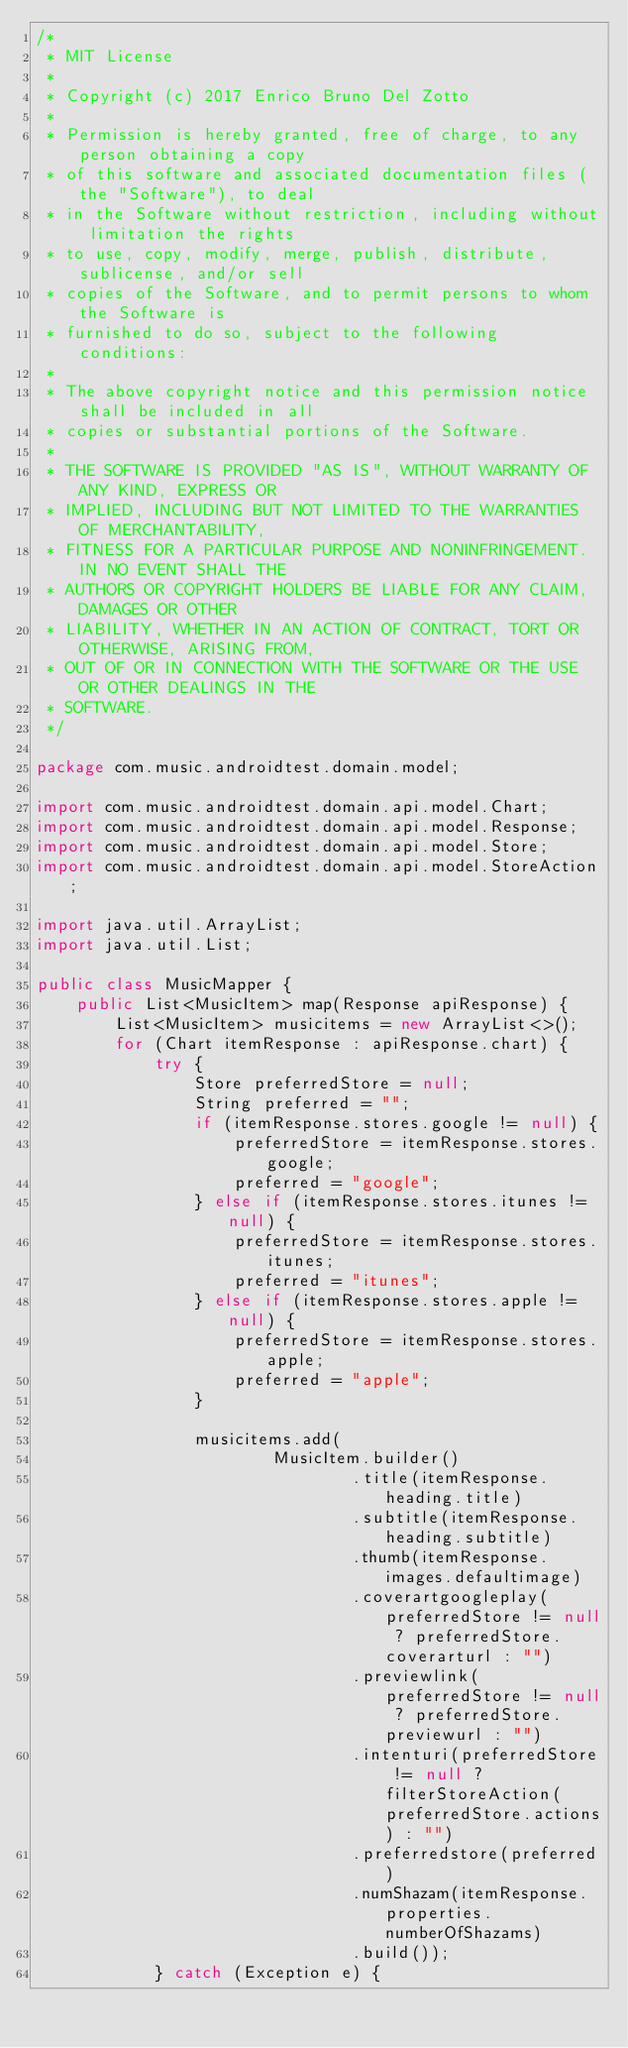Convert code to text. <code><loc_0><loc_0><loc_500><loc_500><_Java_>/*
 * MIT License
 *
 * Copyright (c) 2017 Enrico Bruno Del Zotto
 *
 * Permission is hereby granted, free of charge, to any person obtaining a copy
 * of this software and associated documentation files (the "Software"), to deal
 * in the Software without restriction, including without limitation the rights
 * to use, copy, modify, merge, publish, distribute, sublicense, and/or sell
 * copies of the Software, and to permit persons to whom the Software is
 * furnished to do so, subject to the following conditions:
 *
 * The above copyright notice and this permission notice shall be included in all
 * copies or substantial portions of the Software.
 *
 * THE SOFTWARE IS PROVIDED "AS IS", WITHOUT WARRANTY OF ANY KIND, EXPRESS OR
 * IMPLIED, INCLUDING BUT NOT LIMITED TO THE WARRANTIES OF MERCHANTABILITY,
 * FITNESS FOR A PARTICULAR PURPOSE AND NONINFRINGEMENT. IN NO EVENT SHALL THE
 * AUTHORS OR COPYRIGHT HOLDERS BE LIABLE FOR ANY CLAIM, DAMAGES OR OTHER
 * LIABILITY, WHETHER IN AN ACTION OF CONTRACT, TORT OR OTHERWISE, ARISING FROM,
 * OUT OF OR IN CONNECTION WITH THE SOFTWARE OR THE USE OR OTHER DEALINGS IN THE
 * SOFTWARE.
 */

package com.music.androidtest.domain.model;

import com.music.androidtest.domain.api.model.Chart;
import com.music.androidtest.domain.api.model.Response;
import com.music.androidtest.domain.api.model.Store;
import com.music.androidtest.domain.api.model.StoreAction;

import java.util.ArrayList;
import java.util.List;

public class MusicMapper {
    public List<MusicItem> map(Response apiResponse) {
        List<MusicItem> musicitems = new ArrayList<>();
        for (Chart itemResponse : apiResponse.chart) {
            try {
                Store preferredStore = null;
                String preferred = "";
                if (itemResponse.stores.google != null) {
                    preferredStore = itemResponse.stores.google;
                    preferred = "google";
                } else if (itemResponse.stores.itunes != null) {
                    preferredStore = itemResponse.stores.itunes;
                    preferred = "itunes";
                } else if (itemResponse.stores.apple != null) {
                    preferredStore = itemResponse.stores.apple;
                    preferred = "apple";
                }

                musicitems.add(
                        MusicItem.builder()
                                .title(itemResponse.heading.title)
                                .subtitle(itemResponse.heading.subtitle)
                                .thumb(itemResponse.images.defaultimage)
                                .coverartgoogleplay(preferredStore != null ? preferredStore.coverarturl : "")
                                .previewlink(preferredStore != null ? preferredStore.previewurl : "")
                                .intenturi(preferredStore != null ? filterStoreAction(preferredStore.actions) : "")
                                .preferredstore(preferred)
                                .numShazam(itemResponse.properties.numberOfShazams)
                                .build());
            } catch (Exception e) {</code> 